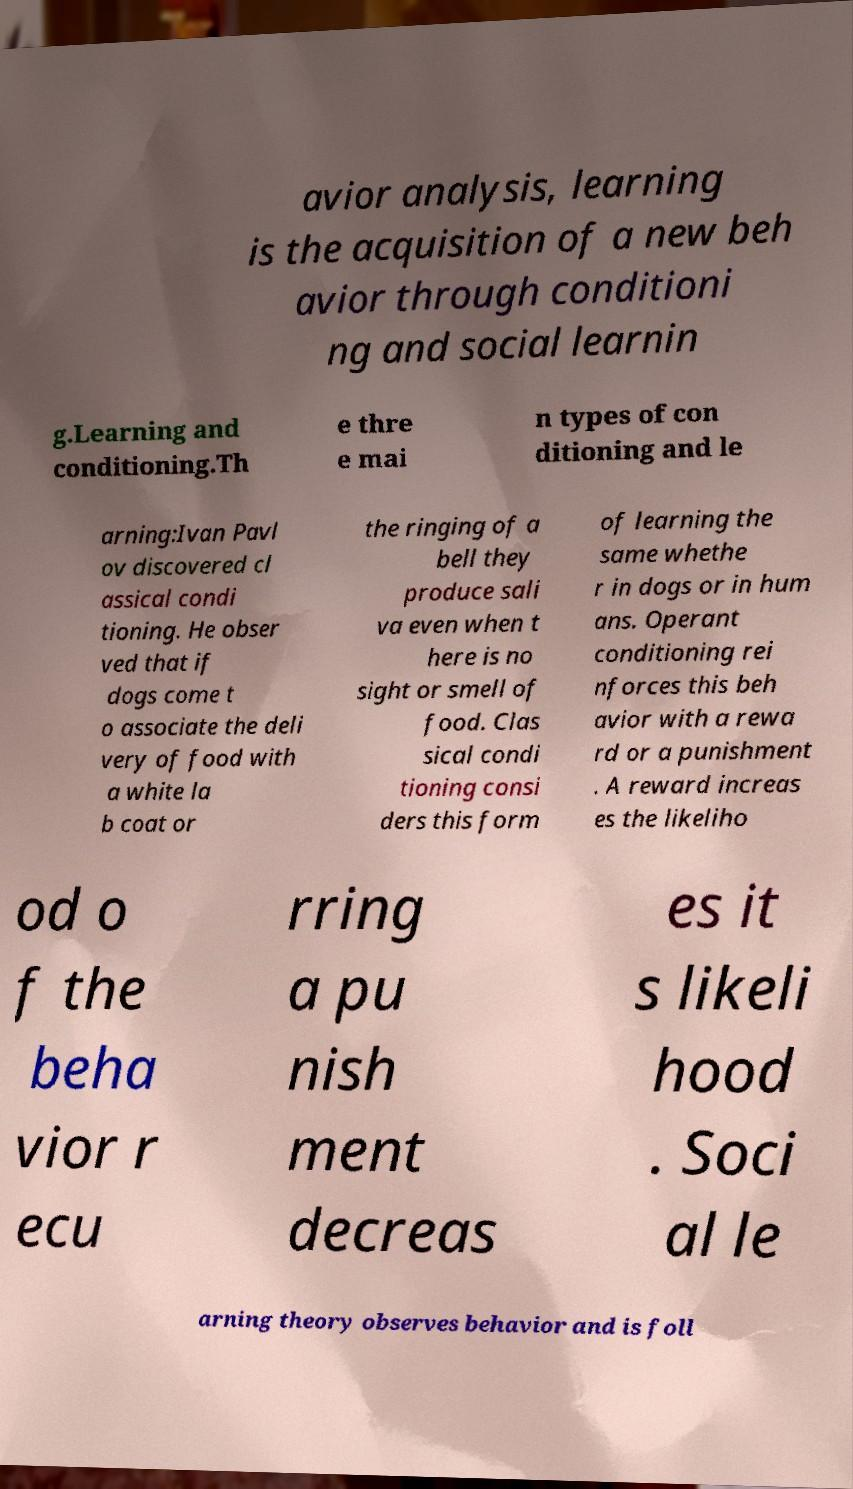Please identify and transcribe the text found in this image. avior analysis, learning is the acquisition of a new beh avior through conditioni ng and social learnin g.Learning and conditioning.Th e thre e mai n types of con ditioning and le arning:Ivan Pavl ov discovered cl assical condi tioning. He obser ved that if dogs come t o associate the deli very of food with a white la b coat or the ringing of a bell they produce sali va even when t here is no sight or smell of food. Clas sical condi tioning consi ders this form of learning the same whethe r in dogs or in hum ans. Operant conditioning rei nforces this beh avior with a rewa rd or a punishment . A reward increas es the likeliho od o f the beha vior r ecu rring a pu nish ment decreas es it s likeli hood . Soci al le arning theory observes behavior and is foll 